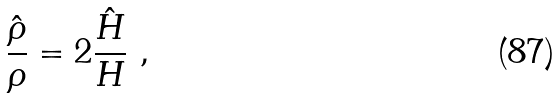<formula> <loc_0><loc_0><loc_500><loc_500>\frac { \hat { \rho } } { \rho } = 2 \frac { \hat { H } } { H } \ ,</formula> 